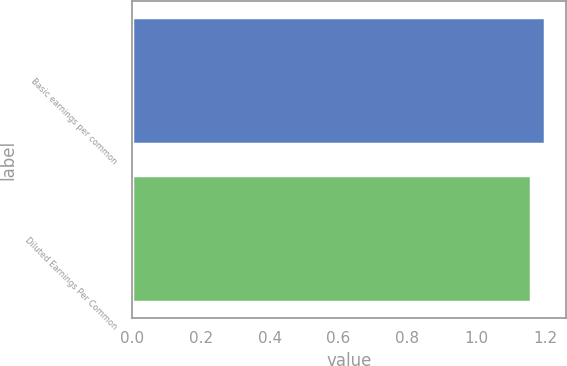Convert chart. <chart><loc_0><loc_0><loc_500><loc_500><bar_chart><fcel>Basic earnings per common<fcel>Diluted Earnings Per Common<nl><fcel>1.2<fcel>1.16<nl></chart> 